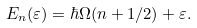<formula> <loc_0><loc_0><loc_500><loc_500>E _ { n } ( \varepsilon ) = \hbar { \Omega } ( n + 1 / 2 ) + \varepsilon .</formula> 